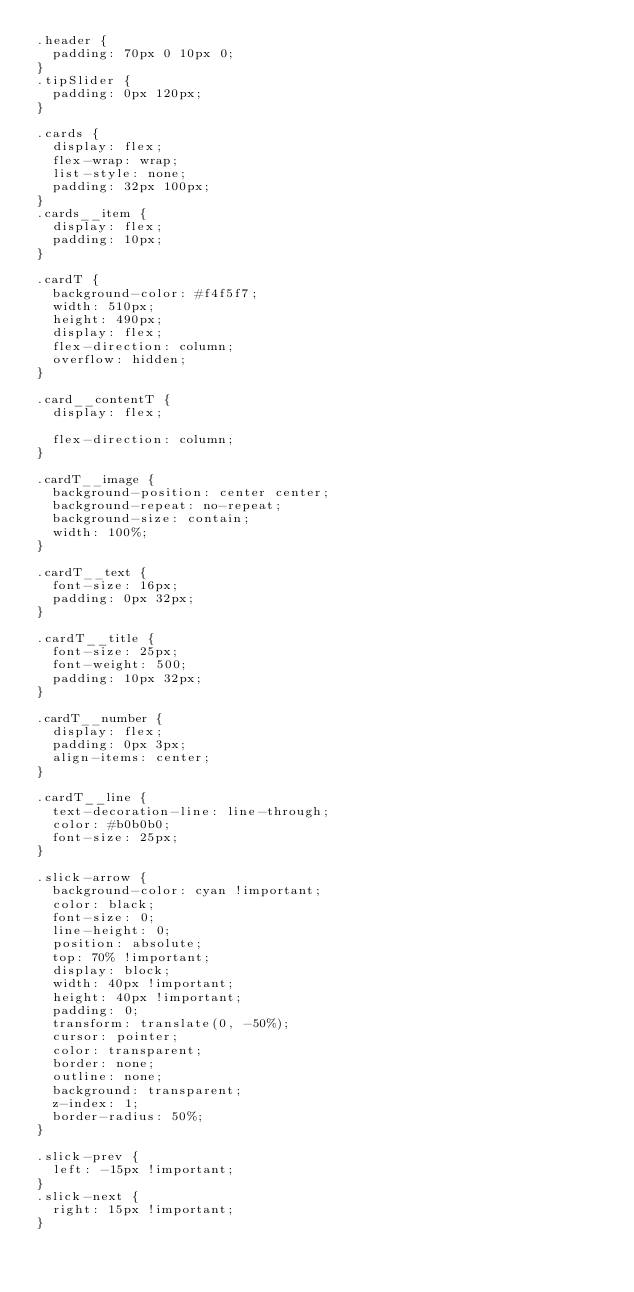Convert code to text. <code><loc_0><loc_0><loc_500><loc_500><_CSS_>.header {
  padding: 70px 0 10px 0;
}
.tipSlider {
  padding: 0px 120px;
}

.cards {
  display: flex;
  flex-wrap: wrap;
  list-style: none;
  padding: 32px 100px;
}
.cards__item {
  display: flex;
  padding: 10px;
}

.cardT {
  background-color: #f4f5f7;
  width: 510px;
  height: 490px;
  display: flex;
  flex-direction: column;
  overflow: hidden;
}

.card__contentT {
  display: flex;

  flex-direction: column;
}

.cardT__image {
  background-position: center center;
  background-repeat: no-repeat;
  background-size: contain;
  width: 100%;
}

.cardT__text {
  font-size: 16px;
  padding: 0px 32px;
}

.cardT__title {
  font-size: 25px;
  font-weight: 500;
  padding: 10px 32px;
}

.cardT__number {
  display: flex;
  padding: 0px 3px;
  align-items: center;
}

.cardT__line {
  text-decoration-line: line-through;
  color: #b0b0b0;
  font-size: 25px;
}

.slick-arrow {
  background-color: cyan !important;
  color: black;
  font-size: 0;
  line-height: 0;
  position: absolute;
  top: 70% !important;
  display: block;
  width: 40px !important;
  height: 40px !important;
  padding: 0;
  transform: translate(0, -50%);
  cursor: pointer;
  color: transparent;
  border: none;
  outline: none;
  background: transparent;
  z-index: 1;
  border-radius: 50%;
}

.slick-prev {
  left: -15px !important;
}
.slick-next {
  right: 15px !important;
}
</code> 